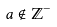Convert formula to latex. <formula><loc_0><loc_0><loc_500><loc_500>a \notin \mathbb { Z } ^ { - }</formula> 